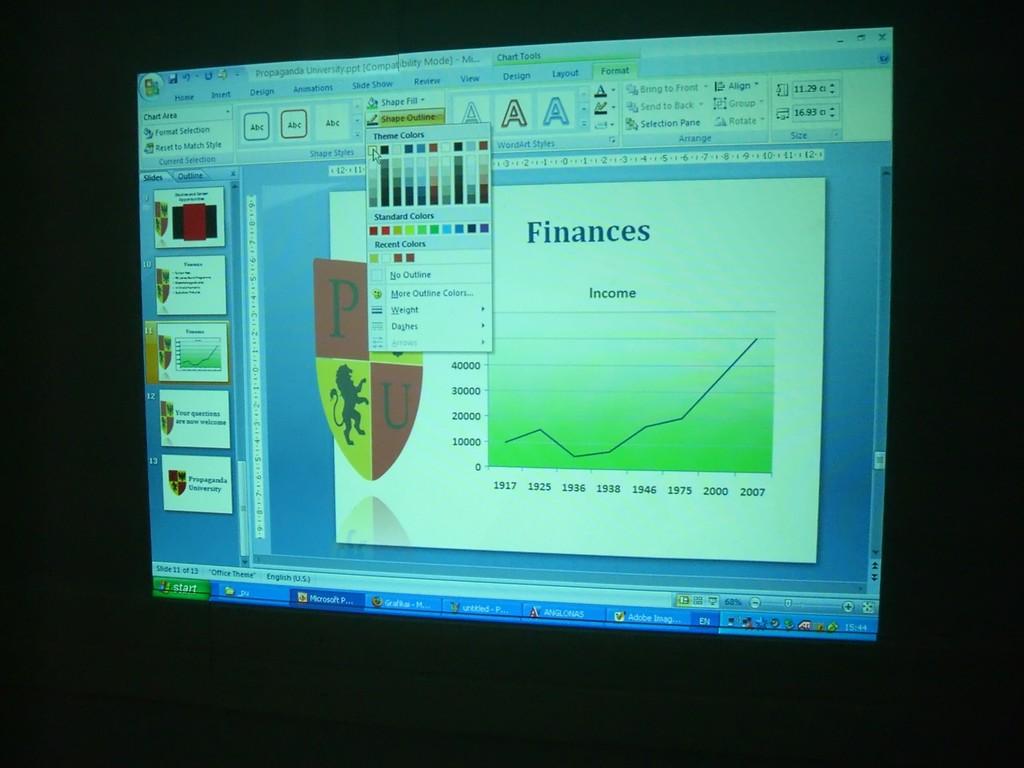What is the name of the button on the bottom left?
Provide a short and direct response. Start. What is the title of the slide?
Provide a short and direct response. Finances. 